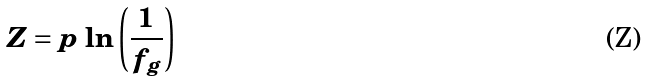Convert formula to latex. <formula><loc_0><loc_0><loc_500><loc_500>Z = p \, \ln \left ( \frac { 1 } { f _ { g } } \right )</formula> 